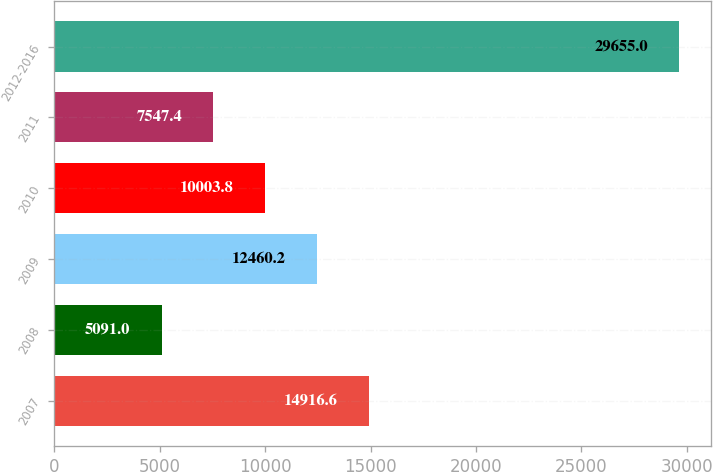Convert chart. <chart><loc_0><loc_0><loc_500><loc_500><bar_chart><fcel>2007<fcel>2008<fcel>2009<fcel>2010<fcel>2011<fcel>2012-2016<nl><fcel>14916.6<fcel>5091<fcel>12460.2<fcel>10003.8<fcel>7547.4<fcel>29655<nl></chart> 